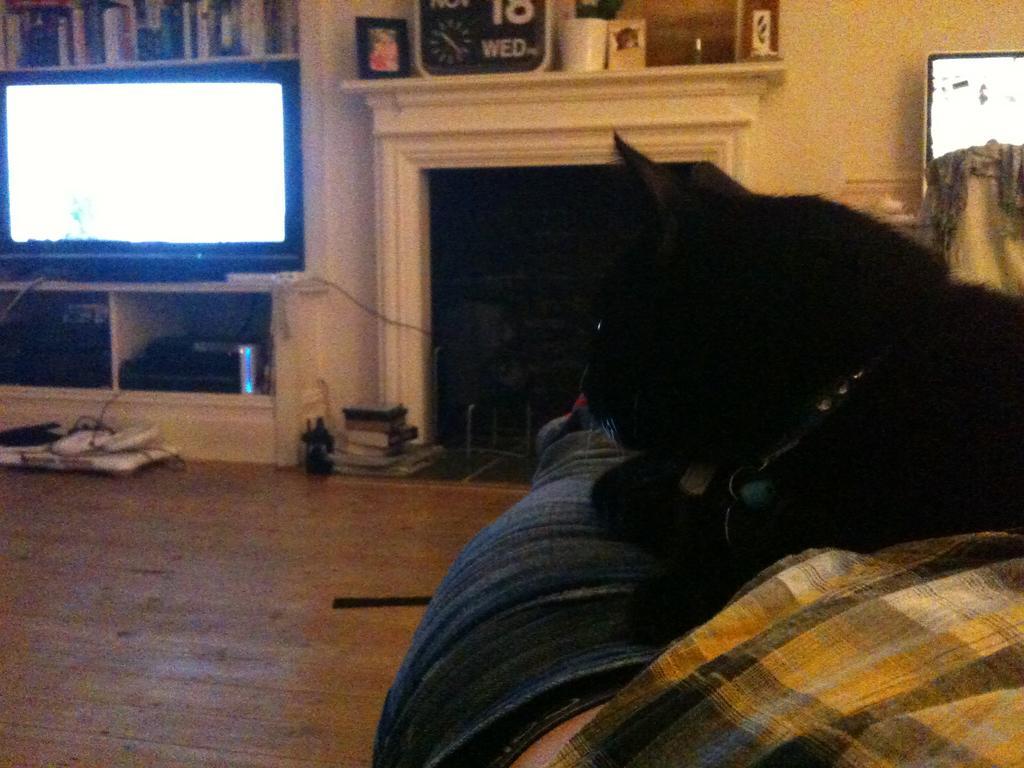Please provide a concise description of this image. This is an indoor picture. On the right side of the picture we can see a man laid on the floor and there is a black cat which is sitting on the man. this is the floor. This is a wall, which is painted in cream colour. On the right side of the picture we can see a television. These are the electronic devices. On the top of the television, we can see a rack and there are books arranged in a sequence manner. This is a flower vase. Beside to it there is a photo frame and this is also a photo frame. 